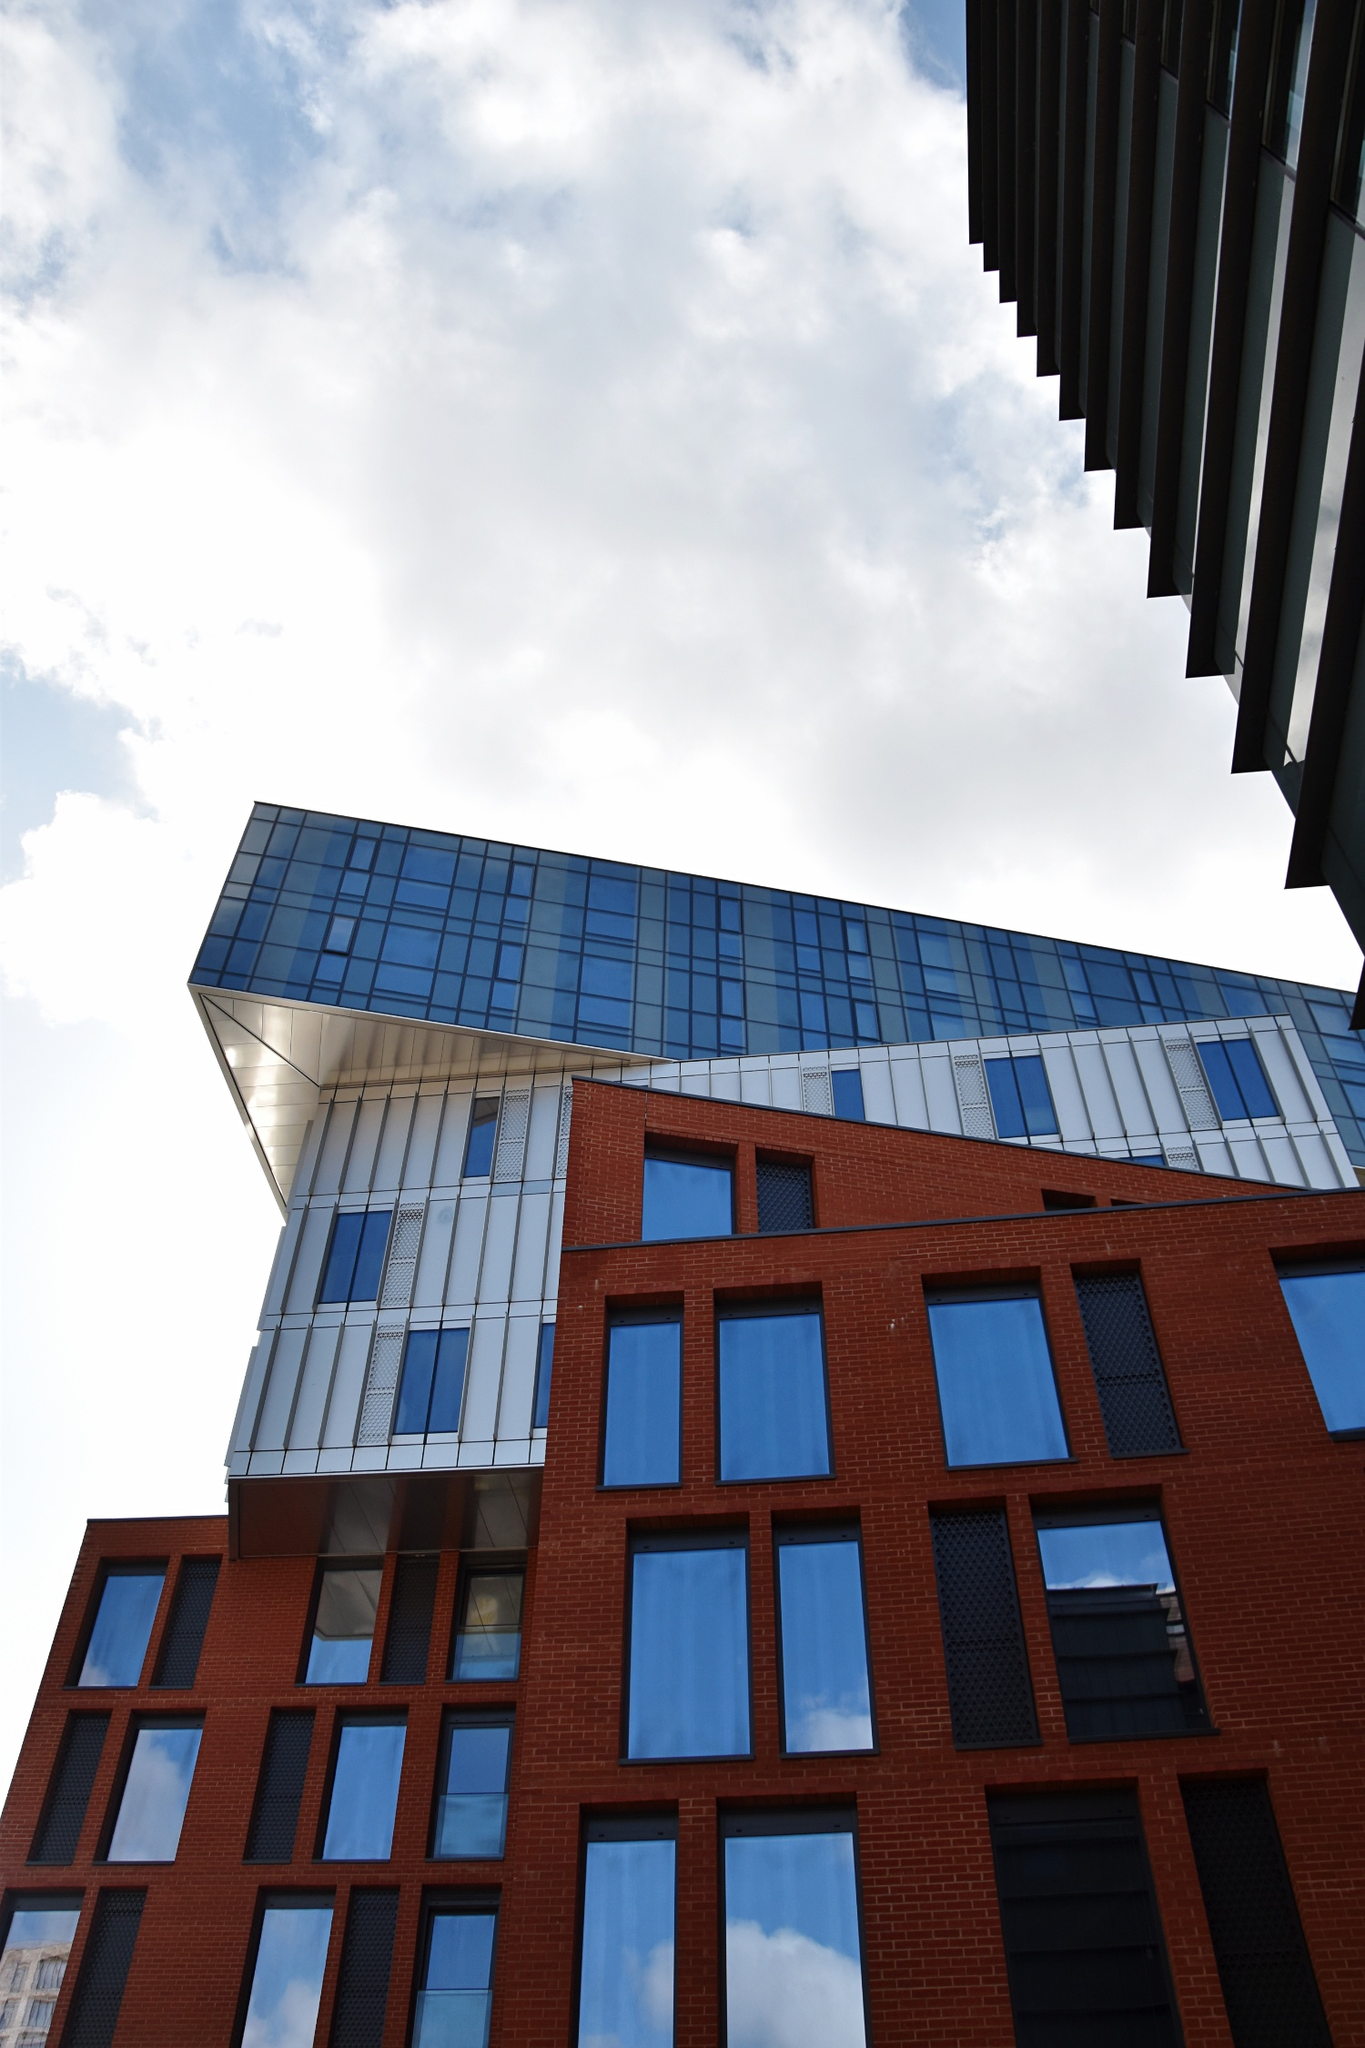Describe the following image. The image captures a striking piece of modern architecture. The lower portion of the building features a red brick facade, imparting a classic touch to the structure. This brick section is decorated with a grid of rectangular windows that add a rhythmic and cohesive visual texture. Transitioning to the upper part of the building, a sleek, blue-tinted glass tower rises from the brick base, jutting out at a sharp angle. This dynamic protrusion creates a unique outline against the sky, making the structure stand out against the backdrop of scattered clouds. The perspective of the photo, taken from a low angle, accentuates the building's impressive height and commanding presence. The mention of 'sa_12985' doesn’t correspond to any widely recognized landmark and may be an internal identifier. If more context about this code could be provided, a more precise identification could be possible. 